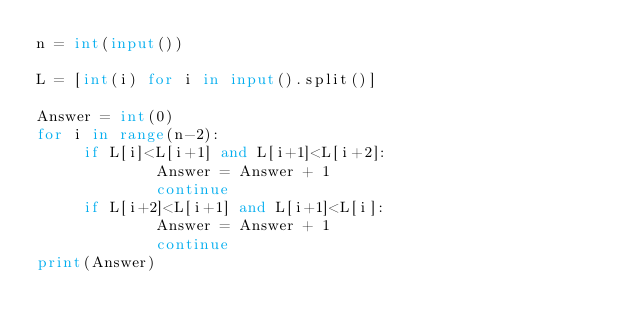<code> <loc_0><loc_0><loc_500><loc_500><_Python_>n = int(input())

L = [int(i) for i in input().split()]

Answer = int(0)
for i in range(n-2):
     if L[i]<L[i+1] and L[i+1]<L[i+2]:
             Answer = Answer + 1
             continue
     if L[i+2]<L[i+1] and L[i+1]<L[i]:
             Answer = Answer + 1
             continue
print(Answer)
</code> 